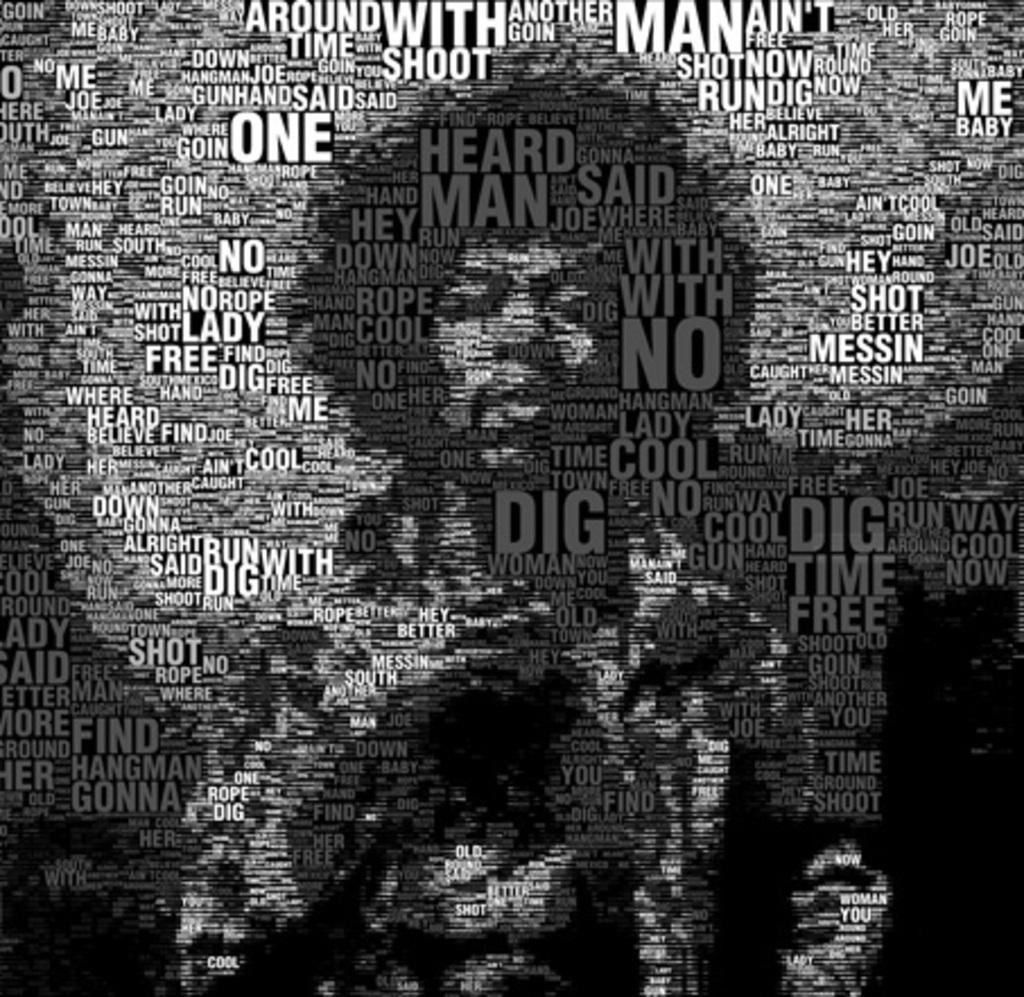What word begins with d and appears many times on the poster?
Make the answer very short. Dig. 